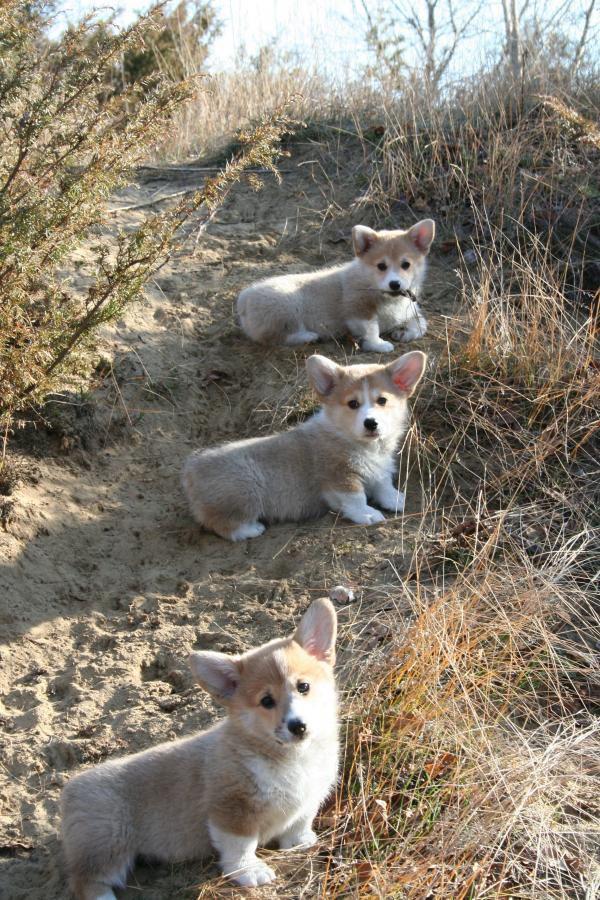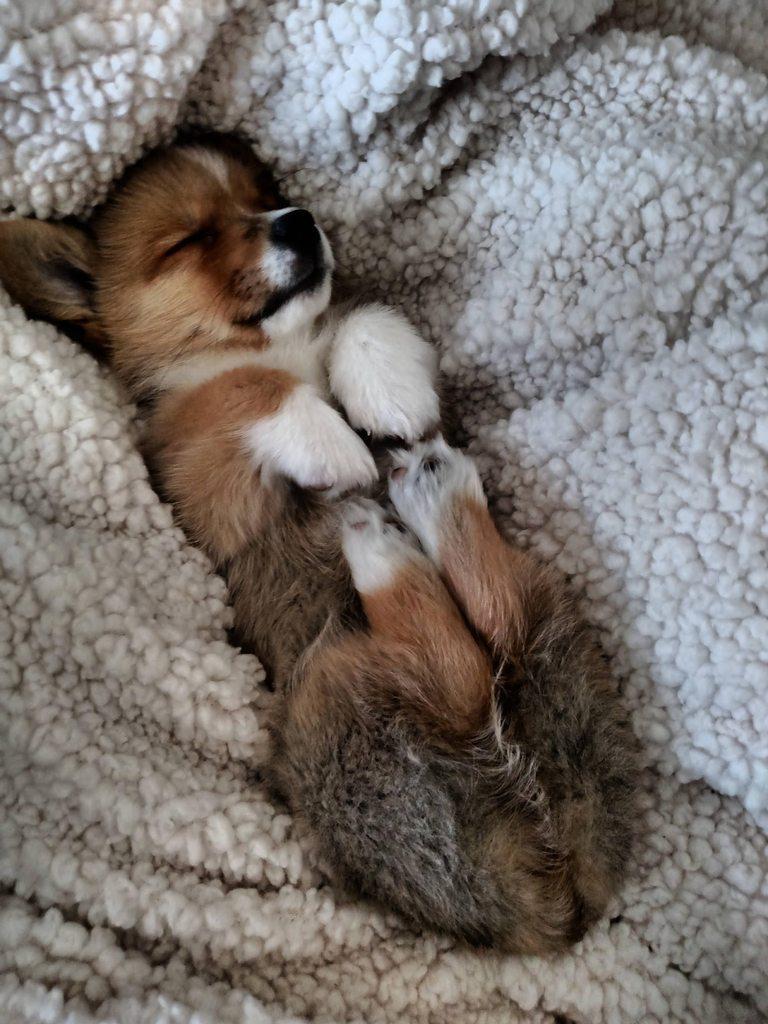The first image is the image on the left, the second image is the image on the right. Examine the images to the left and right. Is the description "One if the images has three dogs looking at the camera." accurate? Answer yes or no. Yes. The first image is the image on the left, the second image is the image on the right. Examine the images to the left and right. Is the description "The left image shows one corgi with its rear to the camera, standing on all fours and looking over one shoulder." accurate? Answer yes or no. No. 